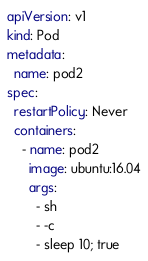<code> <loc_0><loc_0><loc_500><loc_500><_YAML_>apiVersion: v1
kind: Pod
metadata:
  name: pod2
spec:
  restartPolicy: Never
  containers:
    - name: pod2
      image: ubuntu:16.04
      args:
        - sh
        - -c
        - sleep 10; true
</code> 